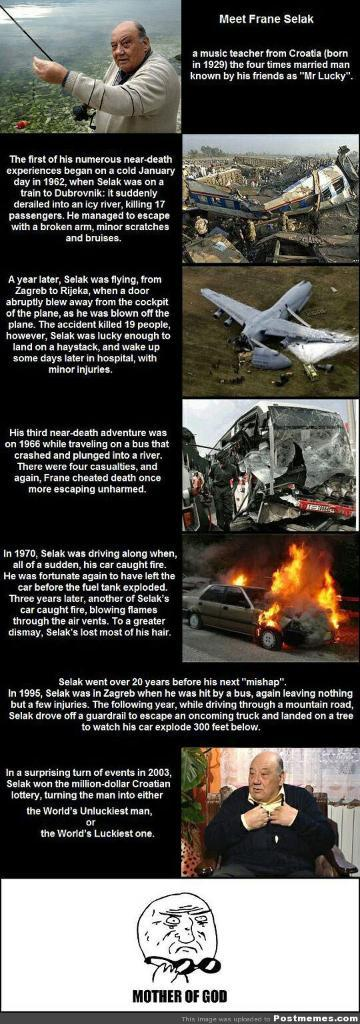<image>
Describe the image concisely. A listing of events in Frane Selak's life. 